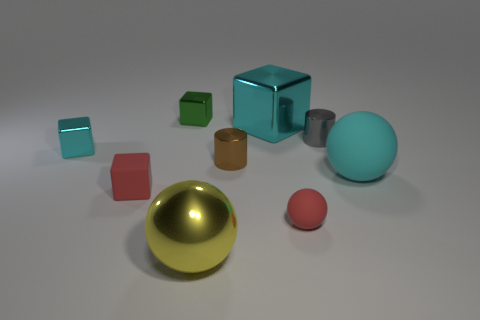Subtract all blue spheres. How many cyan cubes are left? 2 Subtract all shiny cubes. How many cubes are left? 1 Subtract 1 cubes. How many cubes are left? 3 Subtract all purple blocks. Subtract all brown cylinders. How many blocks are left? 4 Add 1 yellow metal balls. How many objects exist? 10 Subtract all cylinders. How many objects are left? 7 Subtract 0 yellow cubes. How many objects are left? 9 Subtract all large purple shiny balls. Subtract all large metal blocks. How many objects are left? 8 Add 3 large metal cubes. How many large metal cubes are left? 4 Add 2 metal cylinders. How many metal cylinders exist? 4 